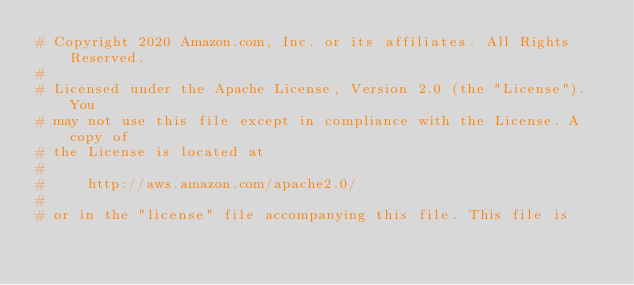<code> <loc_0><loc_0><loc_500><loc_500><_Python_># Copyright 2020 Amazon.com, Inc. or its affiliates. All Rights Reserved.
#
# Licensed under the Apache License, Version 2.0 (the "License"). You
# may not use this file except in compliance with the License. A copy of
# the License is located at
#
#     http://aws.amazon.com/apache2.0/
#
# or in the "license" file accompanying this file. This file is</code> 